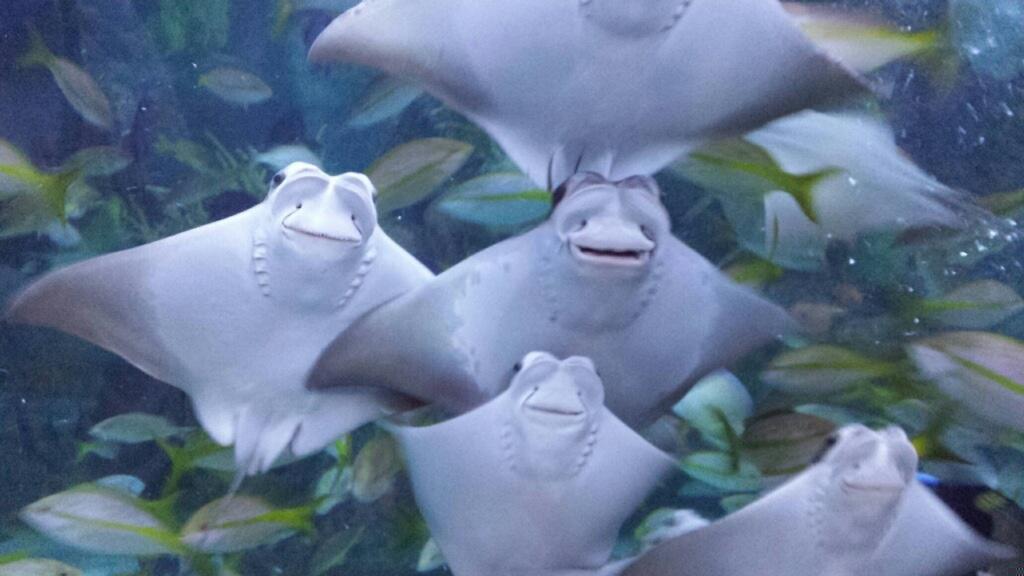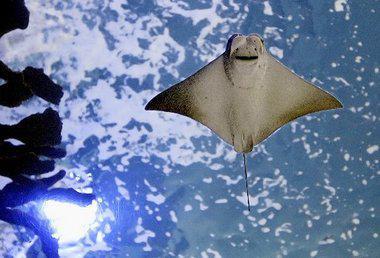The first image is the image on the left, the second image is the image on the right. Given the left and right images, does the statement "In the left image the stingray is near the seabed." hold true? Answer yes or no. No. The first image is the image on the left, the second image is the image on the right. Examine the images to the left and right. Is the description "The left image contains no more than five sting rays." accurate? Answer yes or no. No. 